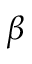Convert formula to latex. <formula><loc_0><loc_0><loc_500><loc_500>\beta</formula> 